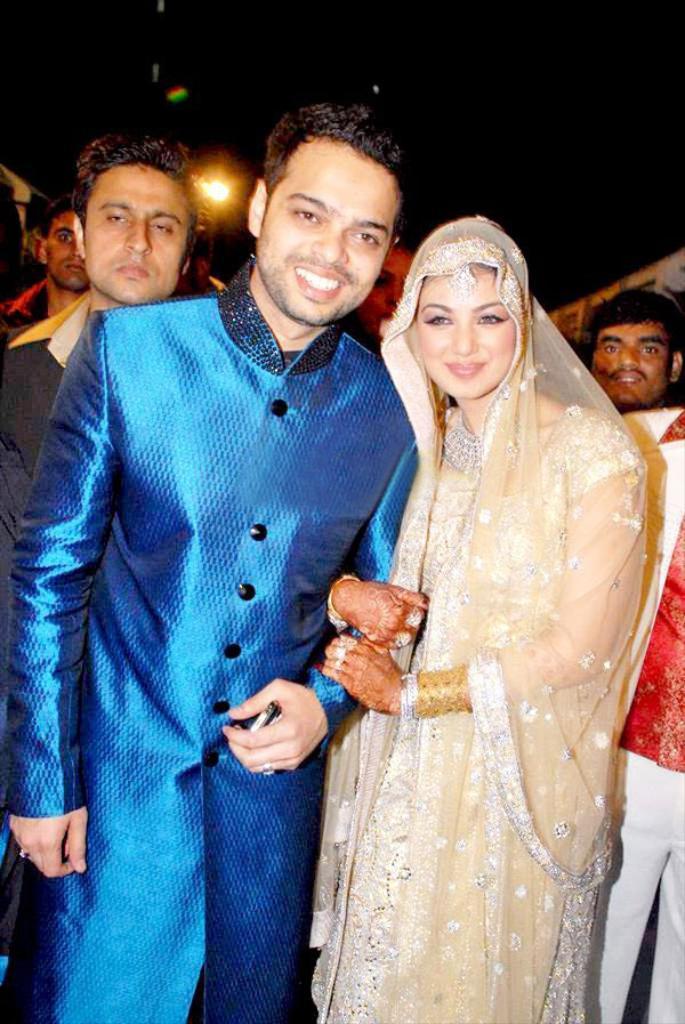In one or two sentences, can you explain what this image depicts? In this image we can see a man and a woman. The man is wearing a blue color dress and the woman is wearing a traditional dress. In the background, we can see so many people. At the top of the image, we can see a light. 